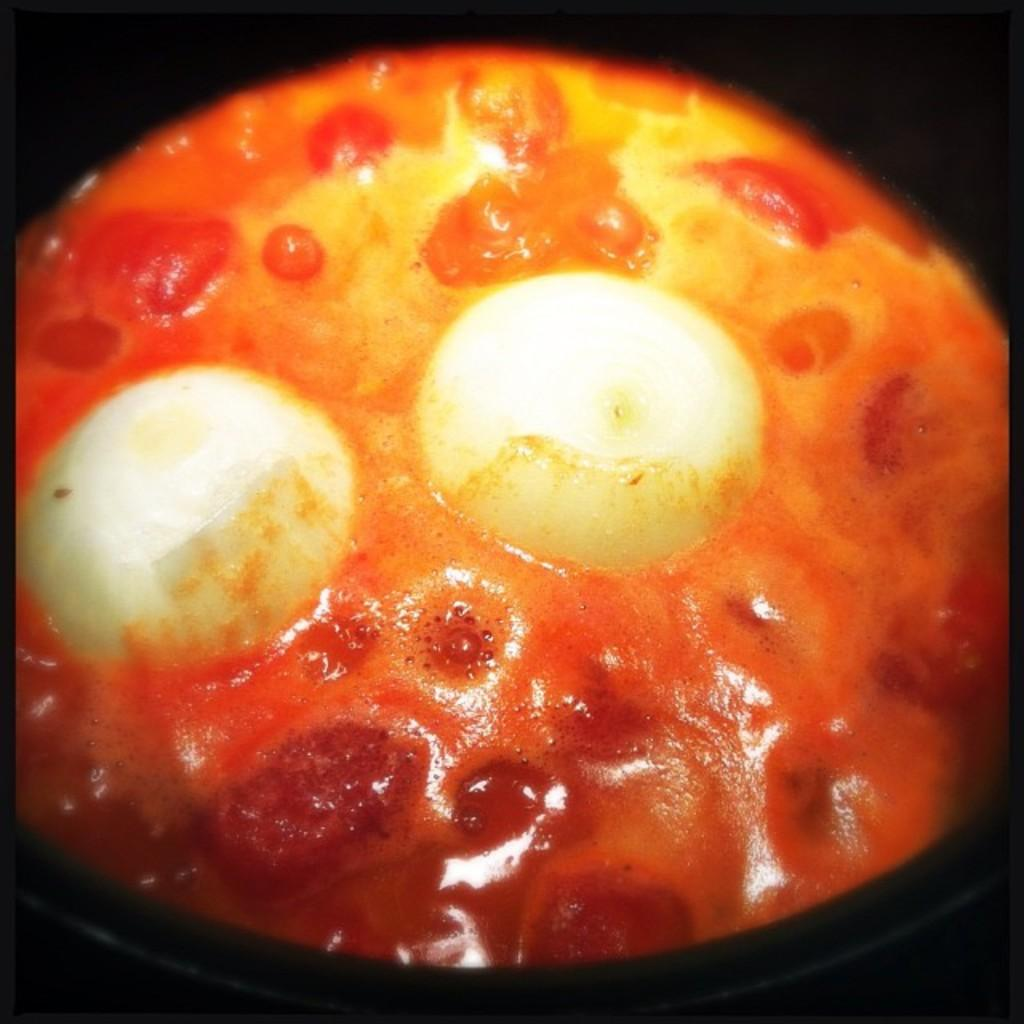What colors are present in the objects in the image? The objects in the image are in white, red, and yellow colors. What can be said about the background of the image? The background of the image is dark. Is there a note attached to the soda can in the image? There is no soda can or note present in the image. What type of animals can be seen on the farm in the image? There is no farm or animals present in the image. 